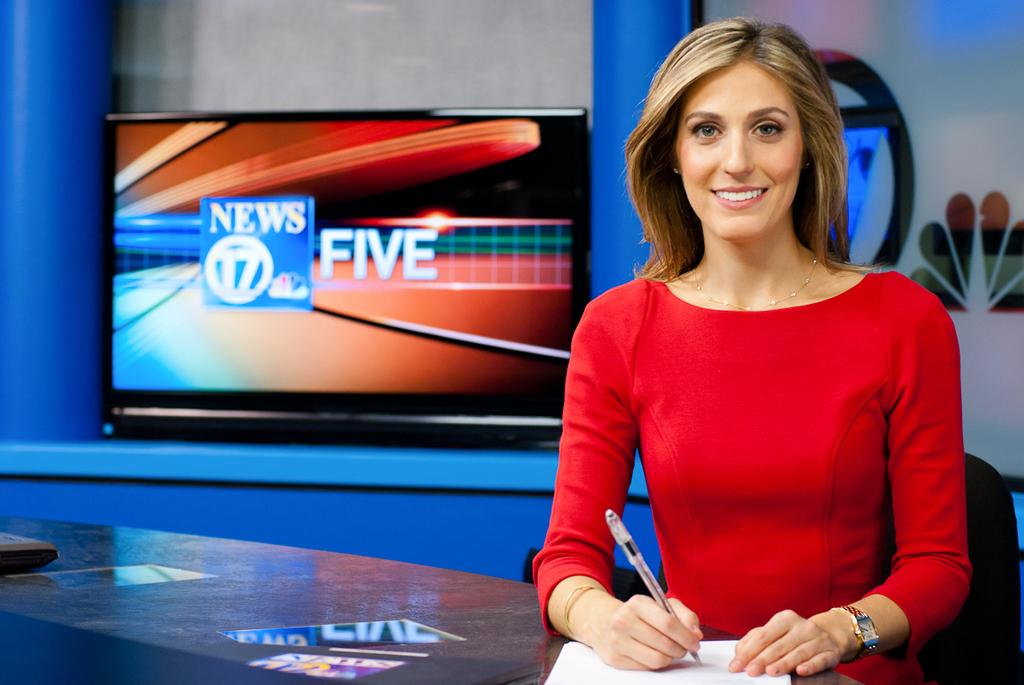Who is present in the image? There is a woman in the image. What is the woman doing in the image? The woman is smiling and holding a paper. Is there another paper visible in the image? Yes, there is a paper in front of the woman. What can be seen in the background of the image? There is a television in the background of the image. What type of stew is being prepared on the television in the image? There is no stew being prepared on the television in the image; it is simply a television visible in the background. 